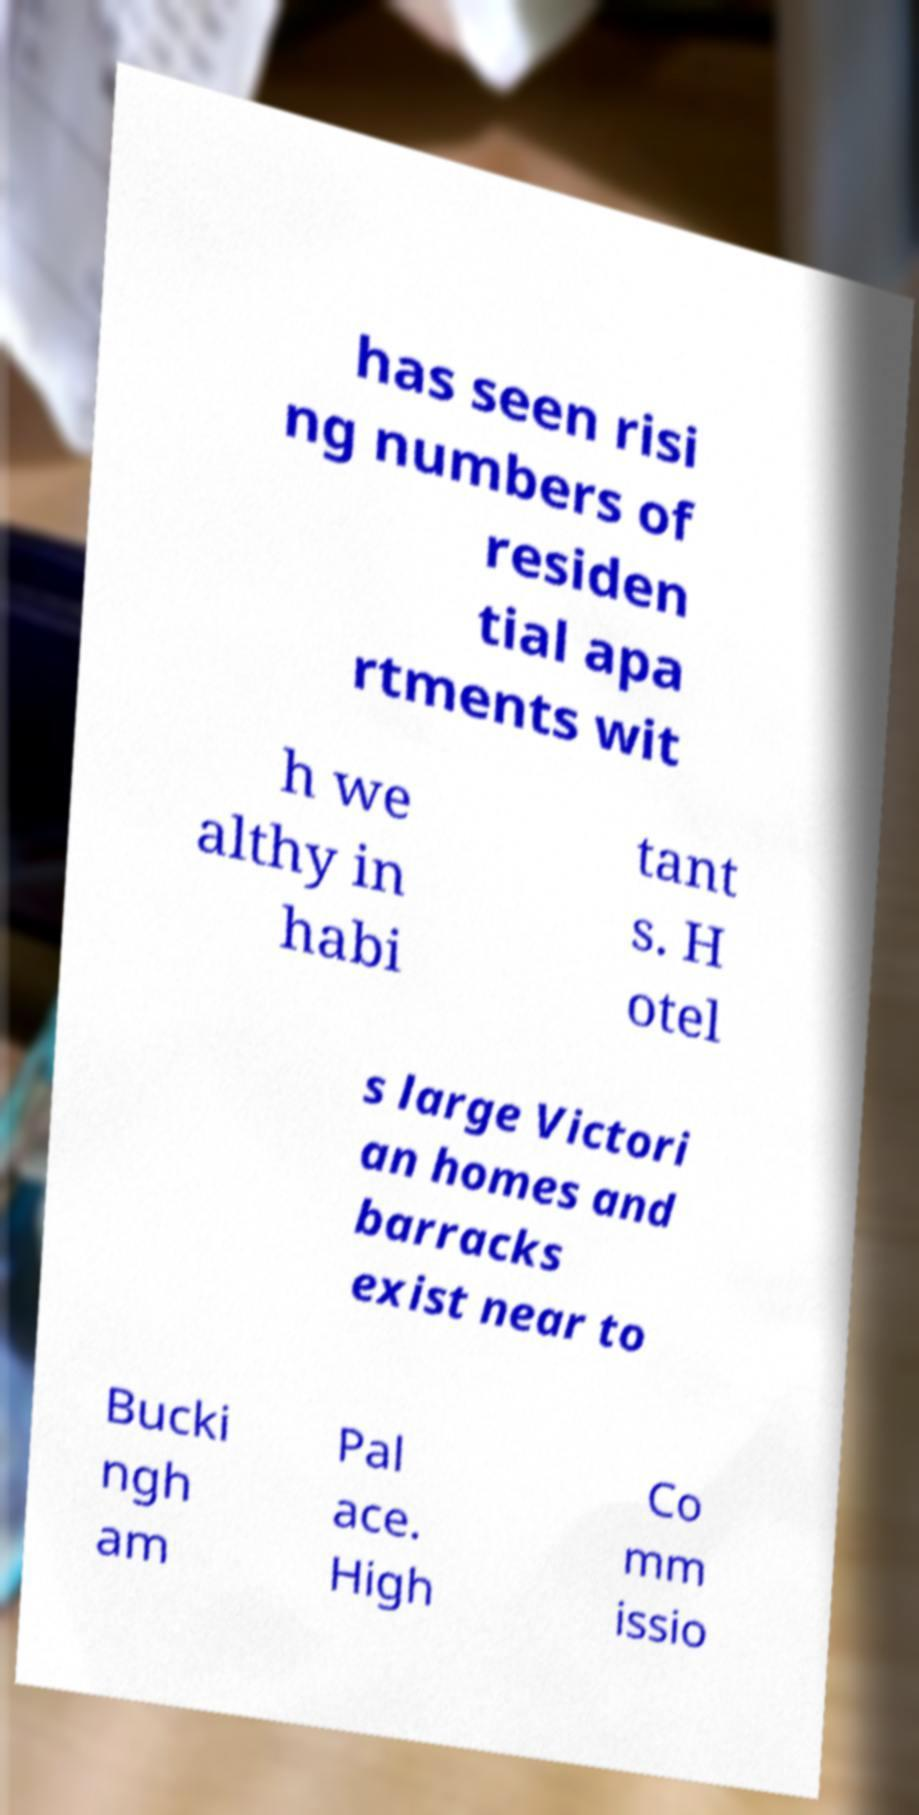There's text embedded in this image that I need extracted. Can you transcribe it verbatim? has seen risi ng numbers of residen tial apa rtments wit h we althy in habi tant s. H otel s large Victori an homes and barracks exist near to Bucki ngh am Pal ace. High Co mm issio 